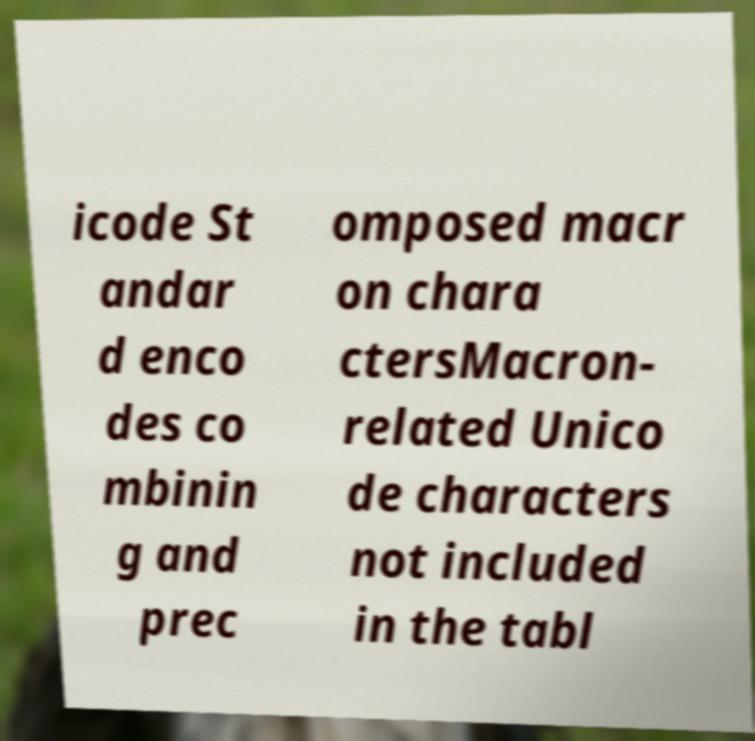Can you read and provide the text displayed in the image?This photo seems to have some interesting text. Can you extract and type it out for me? icode St andar d enco des co mbinin g and prec omposed macr on chara ctersMacron- related Unico de characters not included in the tabl 